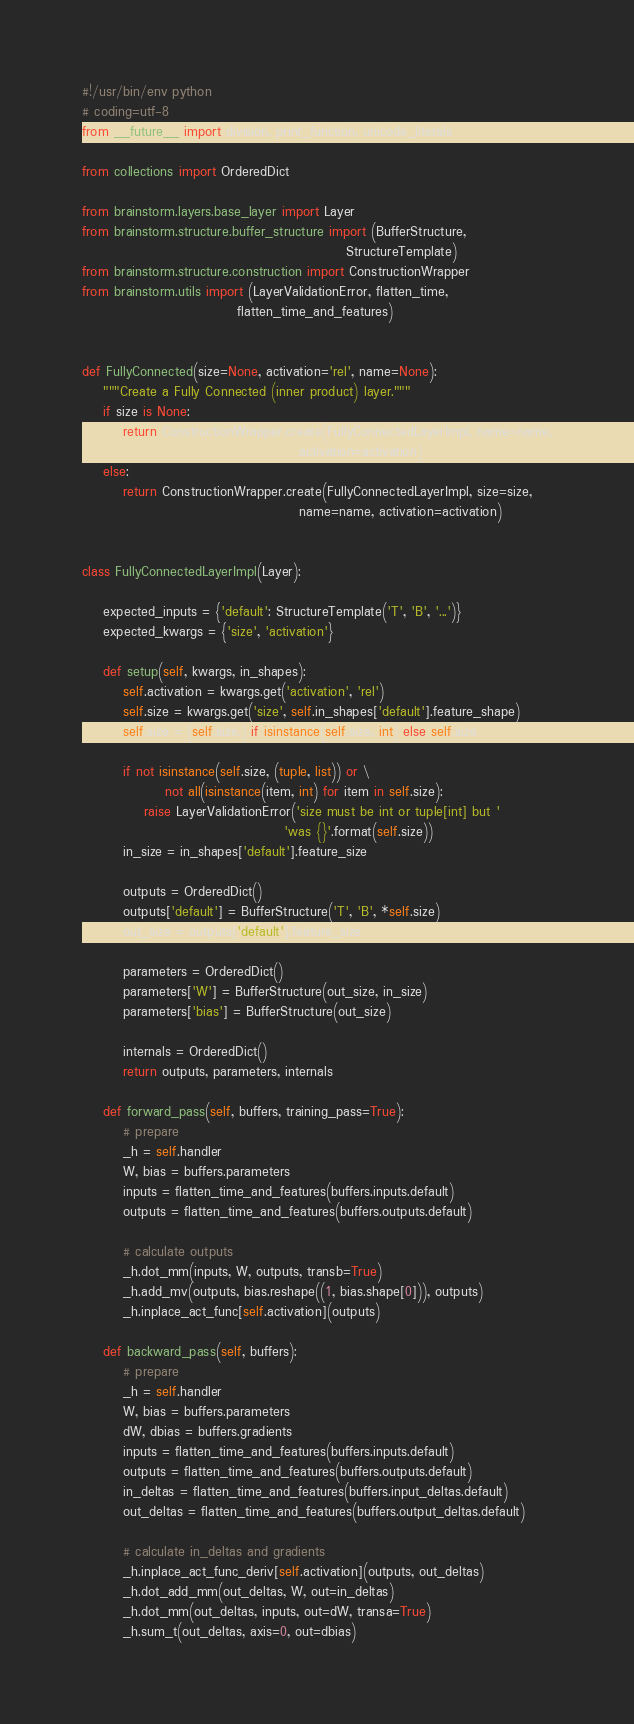<code> <loc_0><loc_0><loc_500><loc_500><_Python_>#!/usr/bin/env python
# coding=utf-8
from __future__ import division, print_function, unicode_literals

from collections import OrderedDict

from brainstorm.layers.base_layer import Layer
from brainstorm.structure.buffer_structure import (BufferStructure,
                                                   StructureTemplate)
from brainstorm.structure.construction import ConstructionWrapper
from brainstorm.utils import (LayerValidationError, flatten_time,
                              flatten_time_and_features)


def FullyConnected(size=None, activation='rel', name=None):
    """Create a Fully Connected (inner product) layer."""
    if size is None:
        return ConstructionWrapper.create(FullyConnectedLayerImpl, name=name,
                                          activation=activation)
    else:
        return ConstructionWrapper.create(FullyConnectedLayerImpl, size=size,
                                          name=name, activation=activation)


class FullyConnectedLayerImpl(Layer):

    expected_inputs = {'default': StructureTemplate('T', 'B', '...')}
    expected_kwargs = {'size', 'activation'}

    def setup(self, kwargs, in_shapes):
        self.activation = kwargs.get('activation', 'rel')
        self.size = kwargs.get('size', self.in_shapes['default'].feature_shape)
        self.size = (self.size,) if isinstance(self.size, int) else self.size

        if not isinstance(self.size, (tuple, list)) or \
                not all(isinstance(item, int) for item in self.size):
            raise LayerValidationError('size must be int or tuple[int] but '
                                       'was {}'.format(self.size))
        in_size = in_shapes['default'].feature_size

        outputs = OrderedDict()
        outputs['default'] = BufferStructure('T', 'B', *self.size)
        out_size = outputs['default'].feature_size

        parameters = OrderedDict()
        parameters['W'] = BufferStructure(out_size, in_size)
        parameters['bias'] = BufferStructure(out_size)

        internals = OrderedDict()
        return outputs, parameters, internals

    def forward_pass(self, buffers, training_pass=True):
        # prepare
        _h = self.handler
        W, bias = buffers.parameters
        inputs = flatten_time_and_features(buffers.inputs.default)
        outputs = flatten_time_and_features(buffers.outputs.default)

        # calculate outputs
        _h.dot_mm(inputs, W, outputs, transb=True)
        _h.add_mv(outputs, bias.reshape((1, bias.shape[0])), outputs)
        _h.inplace_act_func[self.activation](outputs)

    def backward_pass(self, buffers):
        # prepare
        _h = self.handler
        W, bias = buffers.parameters
        dW, dbias = buffers.gradients
        inputs = flatten_time_and_features(buffers.inputs.default)
        outputs = flatten_time_and_features(buffers.outputs.default)
        in_deltas = flatten_time_and_features(buffers.input_deltas.default)
        out_deltas = flatten_time_and_features(buffers.output_deltas.default)

        # calculate in_deltas and gradients
        _h.inplace_act_func_deriv[self.activation](outputs, out_deltas)
        _h.dot_add_mm(out_deltas, W, out=in_deltas)
        _h.dot_mm(out_deltas, inputs, out=dW, transa=True)
        _h.sum_t(out_deltas, axis=0, out=dbias)
</code> 